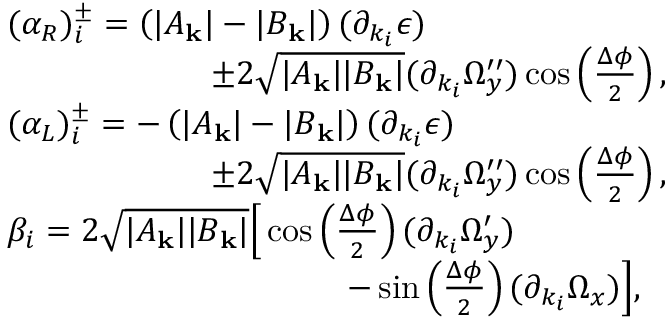Convert formula to latex. <formula><loc_0><loc_0><loc_500><loc_500>\begin{array} { r l } & { ( \alpha _ { R } ) _ { i } ^ { \pm } = \left ( | A _ { k } | - | B _ { k } | \right ) ( \partial _ { k _ { i } } \epsilon ) } \\ & { \quad \pm 2 \sqrt { | A _ { k } | | B _ { k } | } ( \partial _ { k _ { i } } \Omega _ { y } ^ { \prime \prime } ) \cos \left ( \frac { \Delta \phi } { 2 } \right ) , } \\ & { ( \alpha _ { L } ) _ { i } ^ { \pm } = - \left ( | A _ { k } | - | B _ { k } | \right ) ( \partial _ { k _ { i } } \epsilon ) } \\ & { \quad \pm 2 \sqrt { | A _ { k } | | B _ { k } | } ( \partial _ { k _ { i } } \Omega _ { y } ^ { \prime \prime } ) \cos \left ( \frac { \Delta \phi } { 2 } \right ) , } \\ & { \beta _ { i } = 2 \sqrt { | A _ { k } | | B _ { k } | } \left [ \cos \left ( \frac { \Delta \phi } { 2 } \right ) ( \partial _ { k _ { i } } \Omega _ { y } ^ { \prime } ) } \\ & { \quad - \sin \left ( \frac { \Delta \phi } { 2 } \right ) ( \partial _ { k _ { i } } \Omega _ { x } ) \right ] , } \end{array}</formula> 